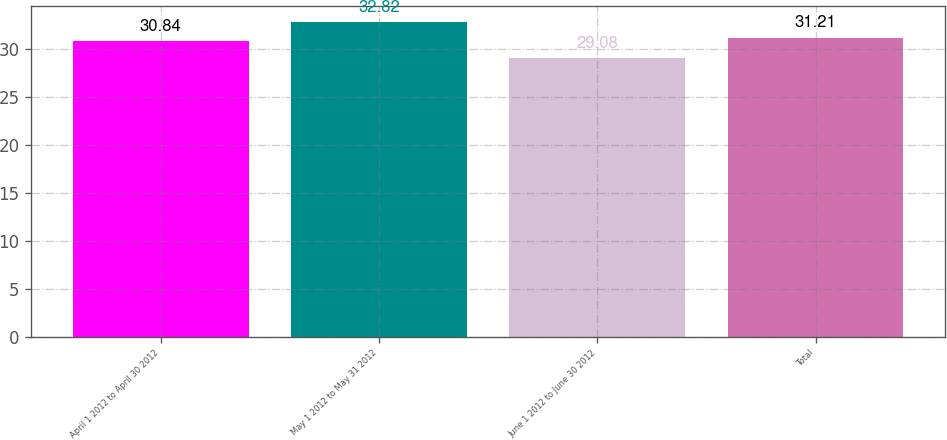<chart> <loc_0><loc_0><loc_500><loc_500><bar_chart><fcel>April 1 2012 to April 30 2012<fcel>May 1 2012 to May 31 2012<fcel>June 1 2012 to June 30 2012<fcel>Total<nl><fcel>30.84<fcel>32.82<fcel>29.08<fcel>31.21<nl></chart> 